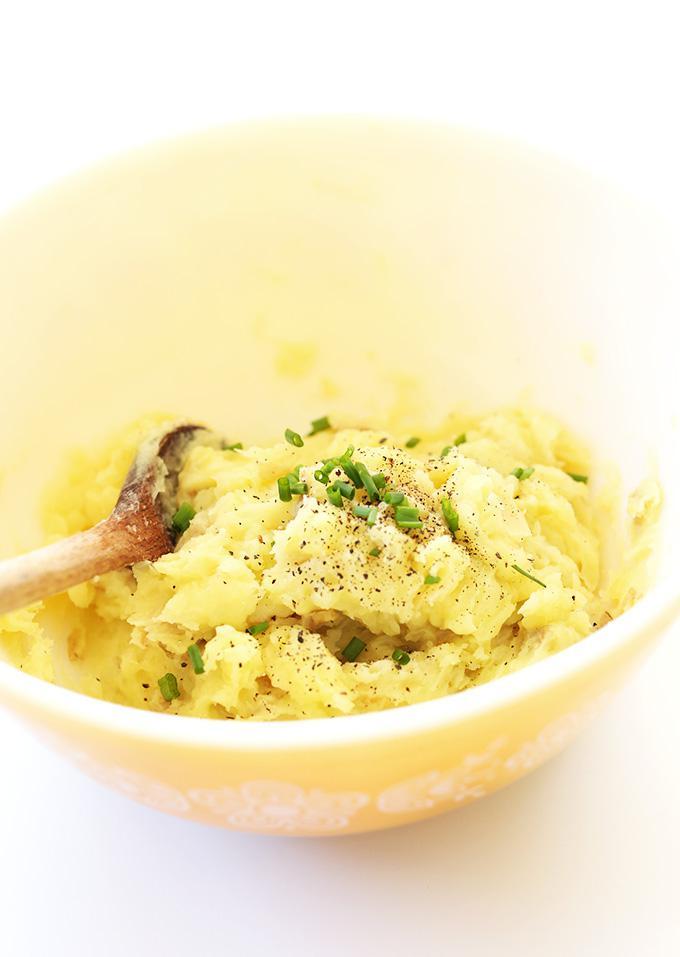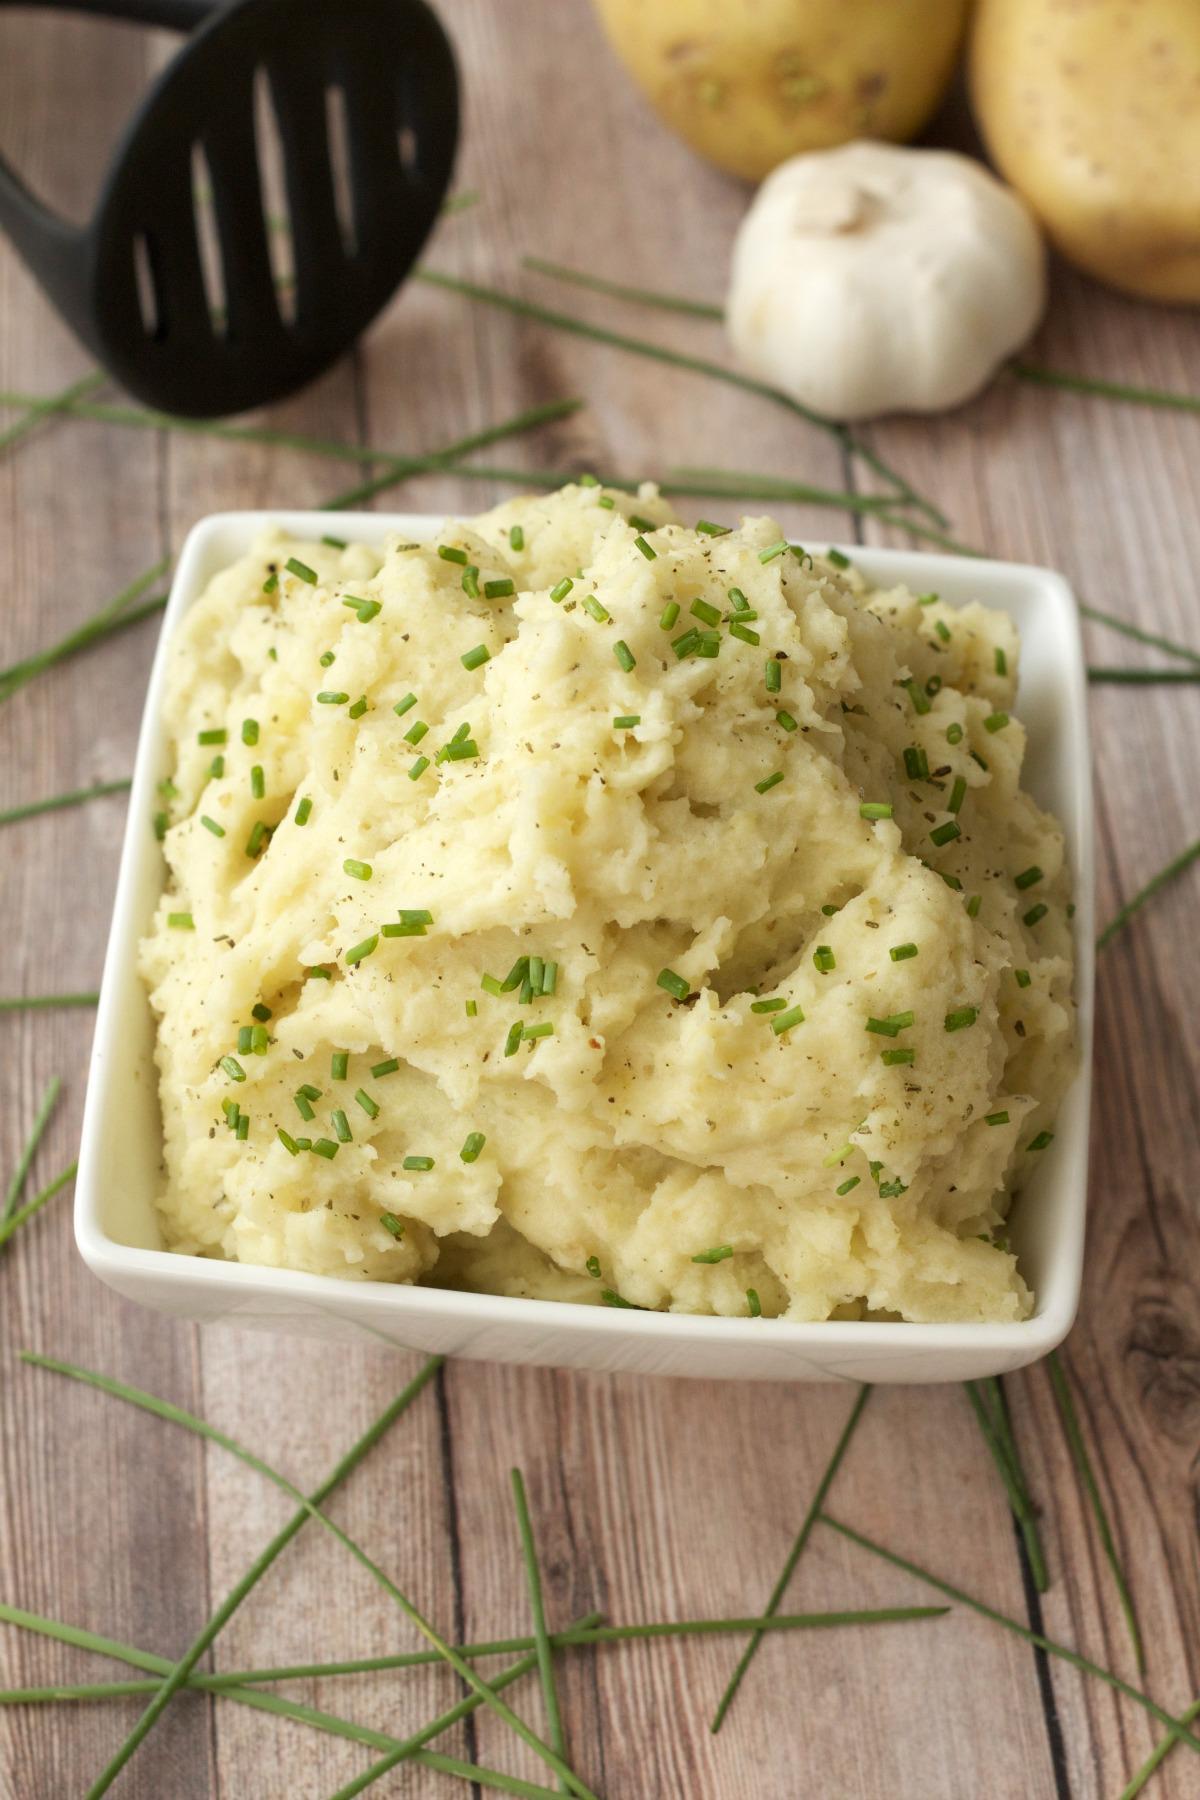The first image is the image on the left, the second image is the image on the right. Given the left and right images, does the statement "One image shows mashed potatoes with chives served in a square white bowl." hold true? Answer yes or no. Yes. 